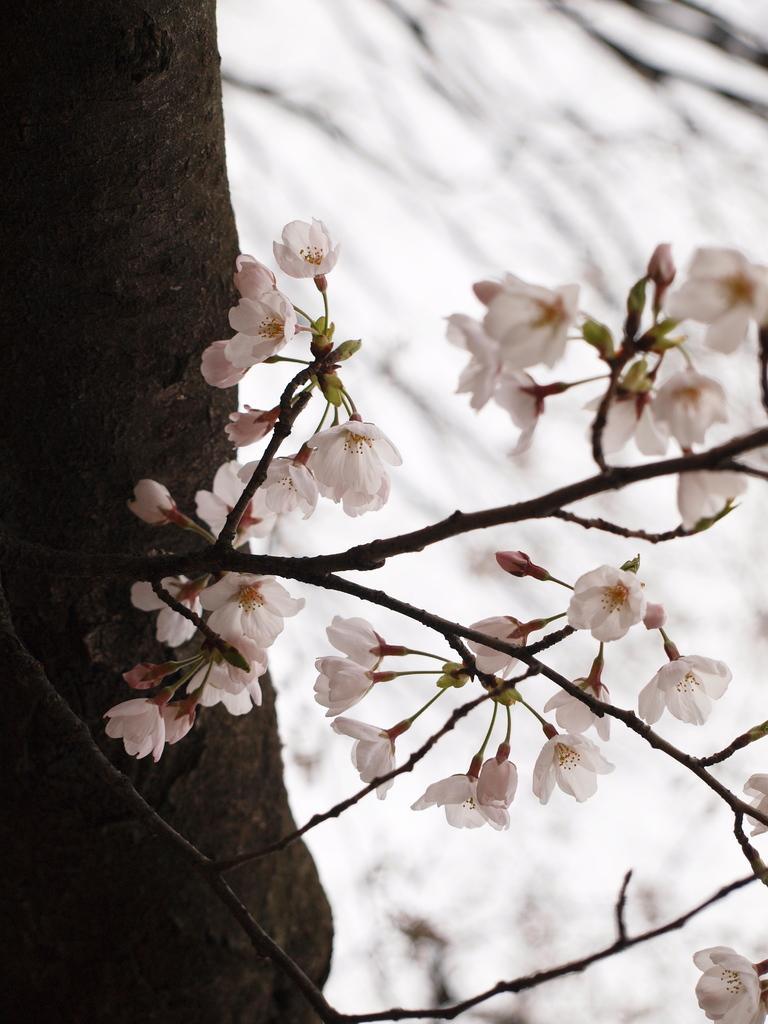Please provide a concise description of this image. This picture shows small white color flowers on the branch. Beside we can see tree trunk. Behind we can see blur background. 